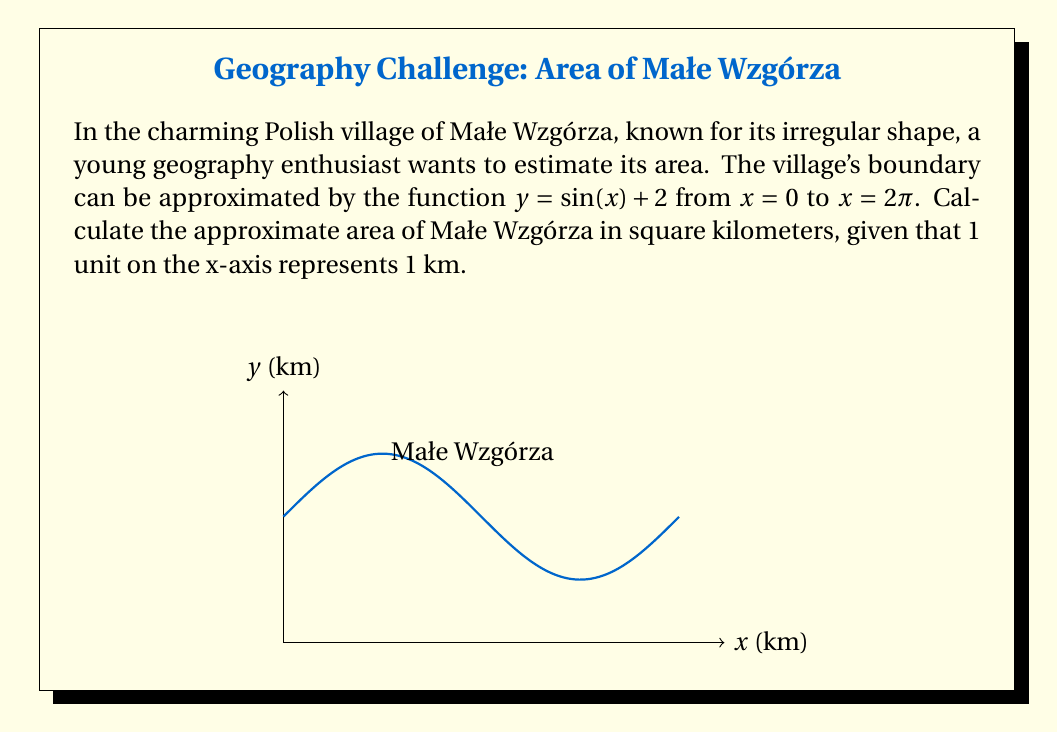Give your solution to this math problem. To estimate the area of the irregularly shaped village, we need to use integration. The area under a curve $y = f(x)$ from $a$ to $b$ is given by the definite integral:

$$A = \int_{a}^{b} f(x) dx$$

In this case, $f(x) = \sin(x) + 2$, $a = 0$, and $b = 2\pi$. So our integral becomes:

$$A = \int_{0}^{2\pi} (\sin(x) + 2) dx$$

Let's solve this step by step:

1) First, let's separate the integral:
   $$A = \int_{0}^{2\pi} \sin(x) dx + \int_{0}^{2\pi} 2 dx$$

2) For the first part, we know that $\int \sin(x) dx = -\cos(x) + C$:
   $$\int_{0}^{2\pi} \sin(x) dx = [-\cos(x)]_{0}^{2\pi} = (-\cos(2\pi)) - (-\cos(0)) = -1 - (-1) = 0$$

3) For the second part, we integrate the constant:
   $$\int_{0}^{2\pi} 2 dx = 2x \Big|_{0}^{2\pi} = 2(2\pi) - 2(0) = 4\pi$$

4) Adding these results:
   $$A = 0 + 4\pi = 4\pi$$

Therefore, the estimated area of Małe Wzgórza is $4\pi$ square kilometers.
Answer: $4\pi$ km² 